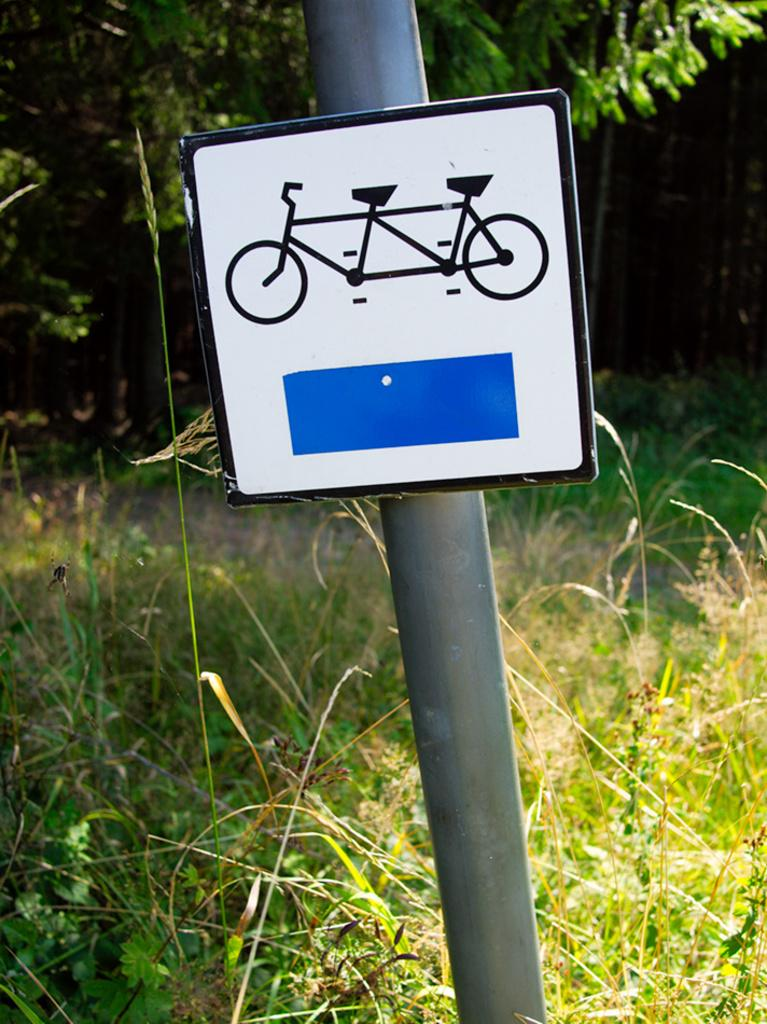What is on the pole in the image? There is a sign board on a pole in the image. What type of plant can be seen in the image? There is a tree in the image. What is covering the ground in the image? Grass is visible on the ground in the image. What type of linen is draped over the tree in the image? There is no linen present in the image; it only features a tree, grass, and a sign board on a pole. 